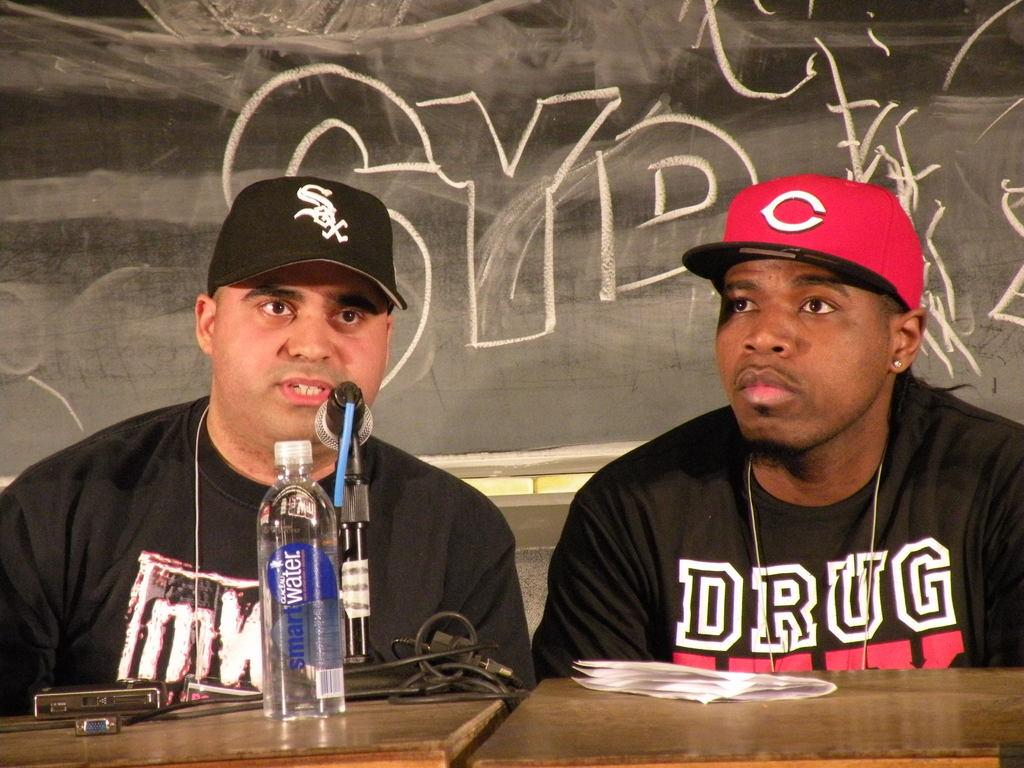<image>
Give a short and clear explanation of the subsequent image. A guy sits at a microphone with a black shirt that has the word drug on it. 